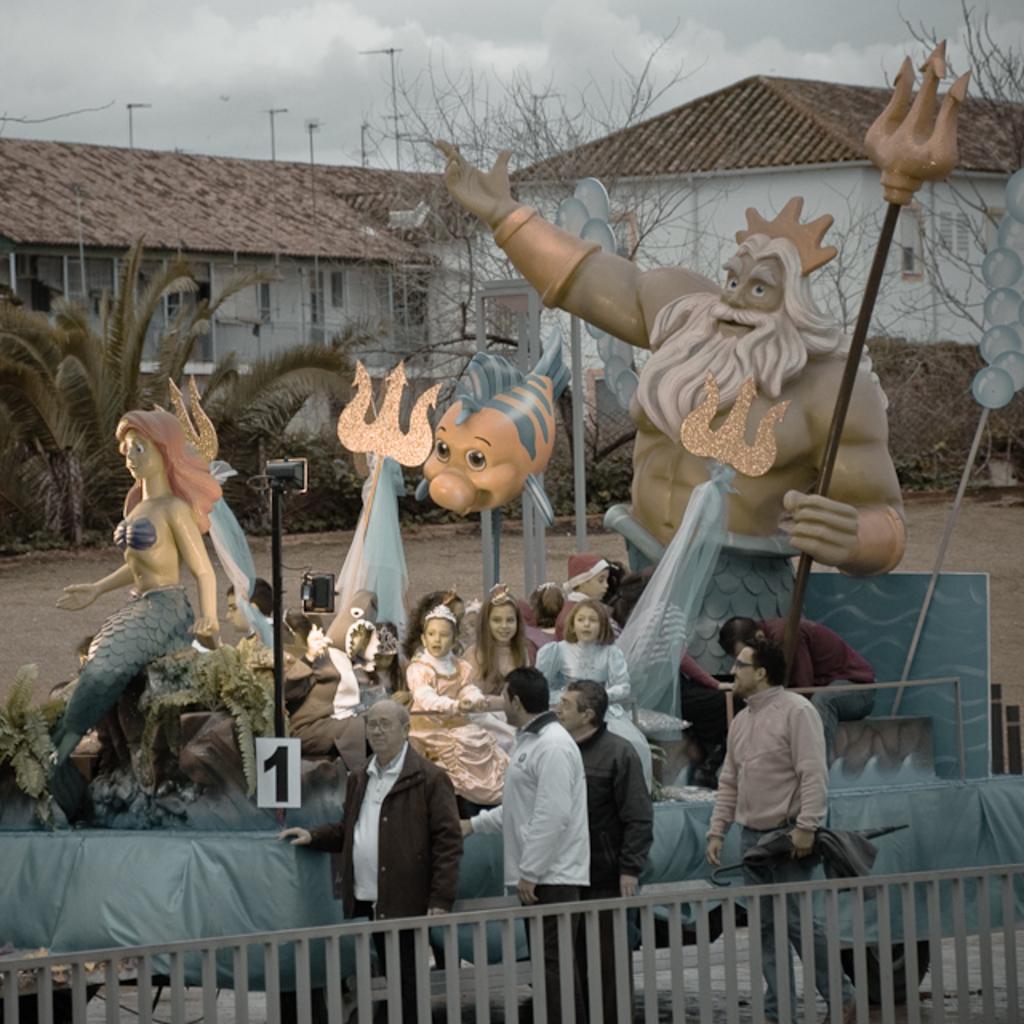How would you summarize this image in a sentence or two? In this image I see a platform on which there are few sculptures and I see few people over here and I see 4 men over here and I see the fencing over here. In the background I see the buildings, trees, poles, ground and the cloudy sky. 